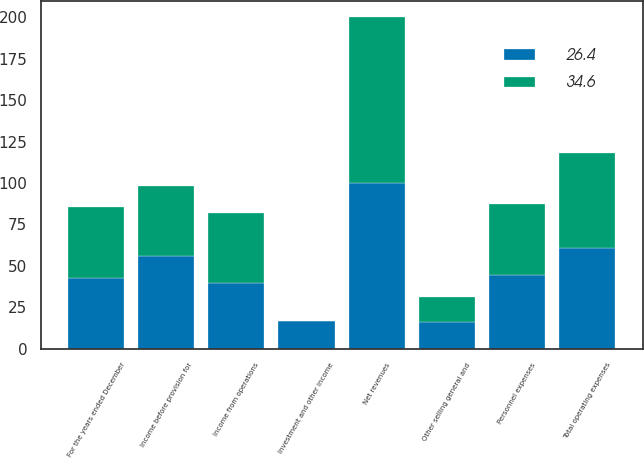Convert chart to OTSL. <chart><loc_0><loc_0><loc_500><loc_500><stacked_bar_chart><ecel><fcel>For the years ended December<fcel>Net revenues<fcel>Personnel expenses<fcel>Other selling general and<fcel>Total operating expenses<fcel>Income from operations<fcel>Investment and other income<fcel>Income before provision for<nl><fcel>26.4<fcel>42.6<fcel>100<fcel>44.6<fcel>16.1<fcel>60.7<fcel>39.3<fcel>16.5<fcel>55.8<nl><fcel>34.6<fcel>42.6<fcel>100<fcel>42.6<fcel>14.9<fcel>57.6<fcel>42.4<fcel>0.1<fcel>42.6<nl></chart> 